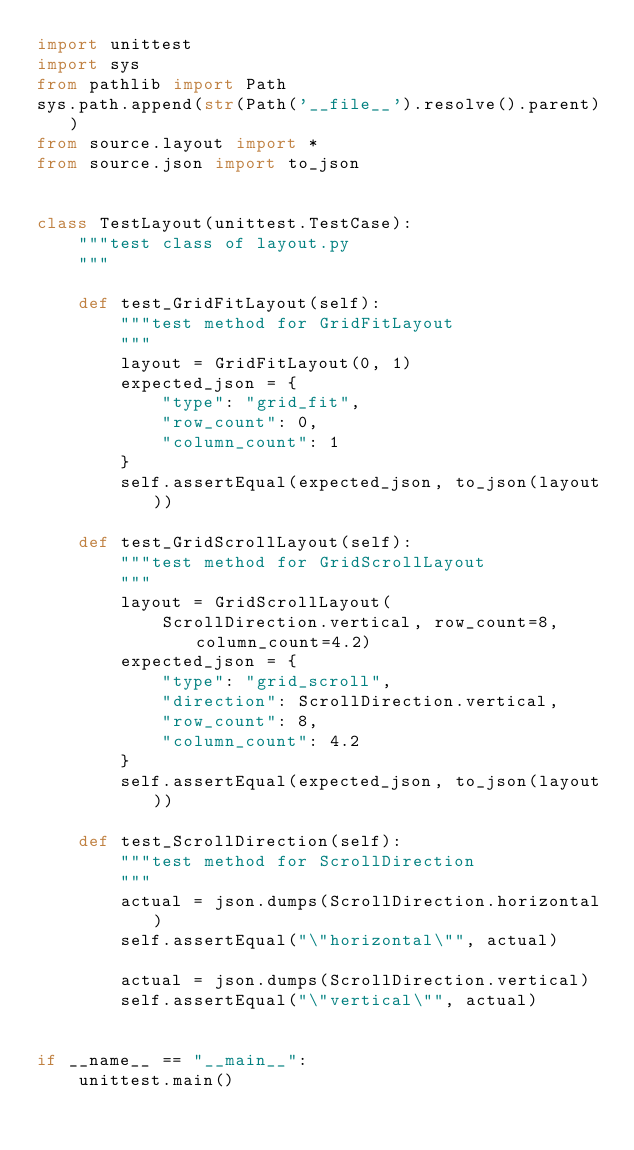<code> <loc_0><loc_0><loc_500><loc_500><_Python_>import unittest
import sys
from pathlib import Path
sys.path.append(str(Path('__file__').resolve().parent))
from source.layout import *
from source.json import to_json


class TestLayout(unittest.TestCase):
    """test class of layout.py
    """

    def test_GridFitLayout(self):
        """test method for GridFitLayout
        """
        layout = GridFitLayout(0, 1)
        expected_json = {
            "type": "grid_fit",
            "row_count": 0,
            "column_count": 1
        }
        self.assertEqual(expected_json, to_json(layout))

    def test_GridScrollLayout(self):
        """test method for GridScrollLayout
        """
        layout = GridScrollLayout(
            ScrollDirection.vertical, row_count=8, column_count=4.2)
        expected_json = {
            "type": "grid_scroll",
            "direction": ScrollDirection.vertical,
            "row_count": 8,
            "column_count": 4.2
        }
        self.assertEqual(expected_json, to_json(layout))

    def test_ScrollDirection(self):
        """test method for ScrollDirection
        """
        actual = json.dumps(ScrollDirection.horizontal)
        self.assertEqual("\"horizontal\"", actual)

        actual = json.dumps(ScrollDirection.vertical)
        self.assertEqual("\"vertical\"", actual)


if __name__ == "__main__":
    unittest.main()
</code> 